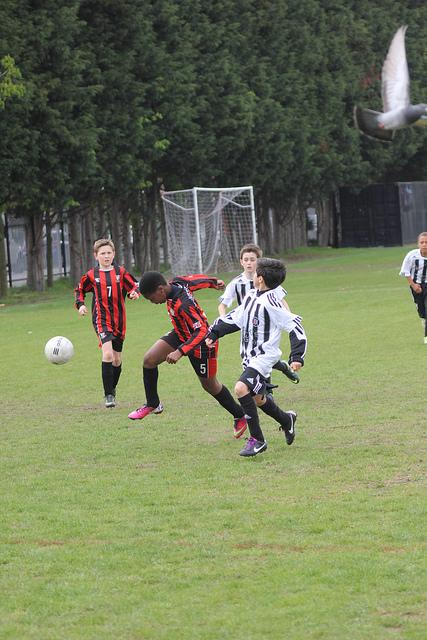What is floating in the air?
Concise answer only. Bird. What  sport is this?
Concise answer only. Soccer. How many red striped shirts?
Concise answer only. 2. What color are the jerseys?
Write a very short answer. Red, blue, white, blue. How many people have their feet completely off the ground?
Short answer required. 1. What sport is being played?
Keep it brief. Soccer. What activity are the individuals in the foreground playing?
Give a very brief answer. Soccer. 